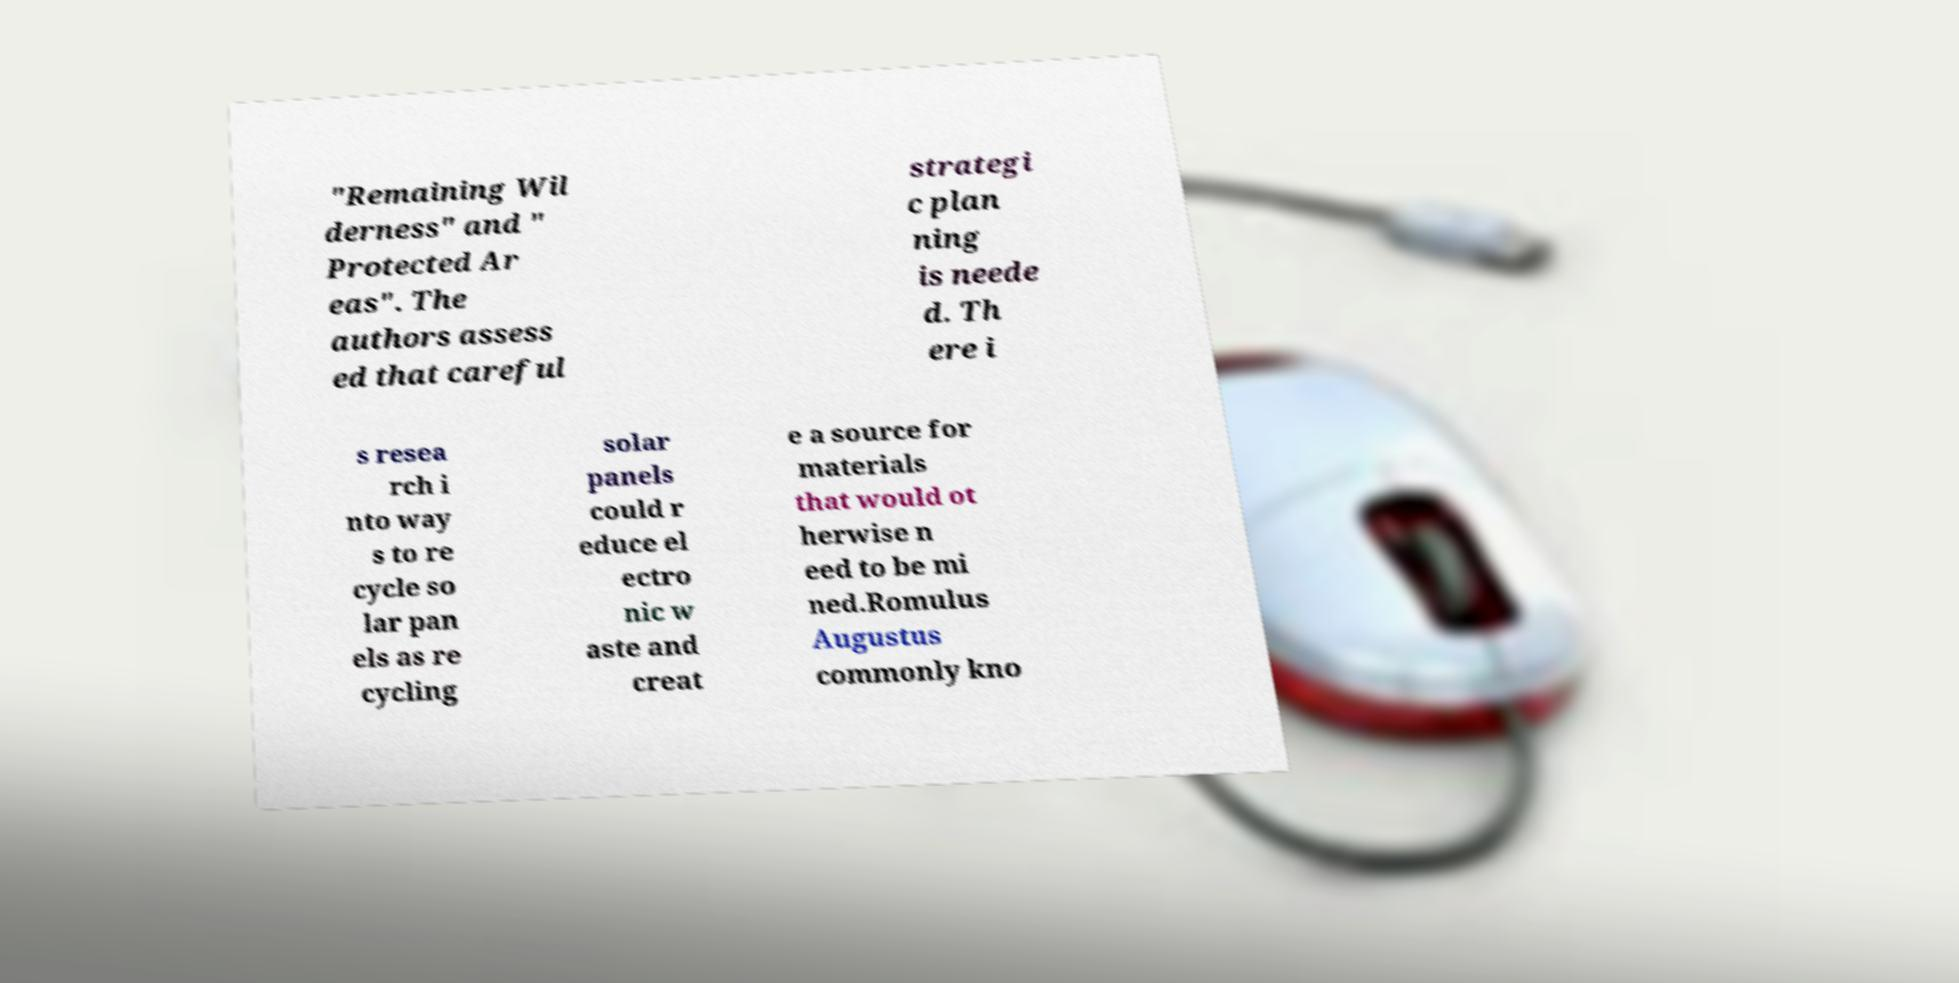Could you assist in decoding the text presented in this image and type it out clearly? "Remaining Wil derness" and " Protected Ar eas". The authors assess ed that careful strategi c plan ning is neede d. Th ere i s resea rch i nto way s to re cycle so lar pan els as re cycling solar panels could r educe el ectro nic w aste and creat e a source for materials that would ot herwise n eed to be mi ned.Romulus Augustus commonly kno 